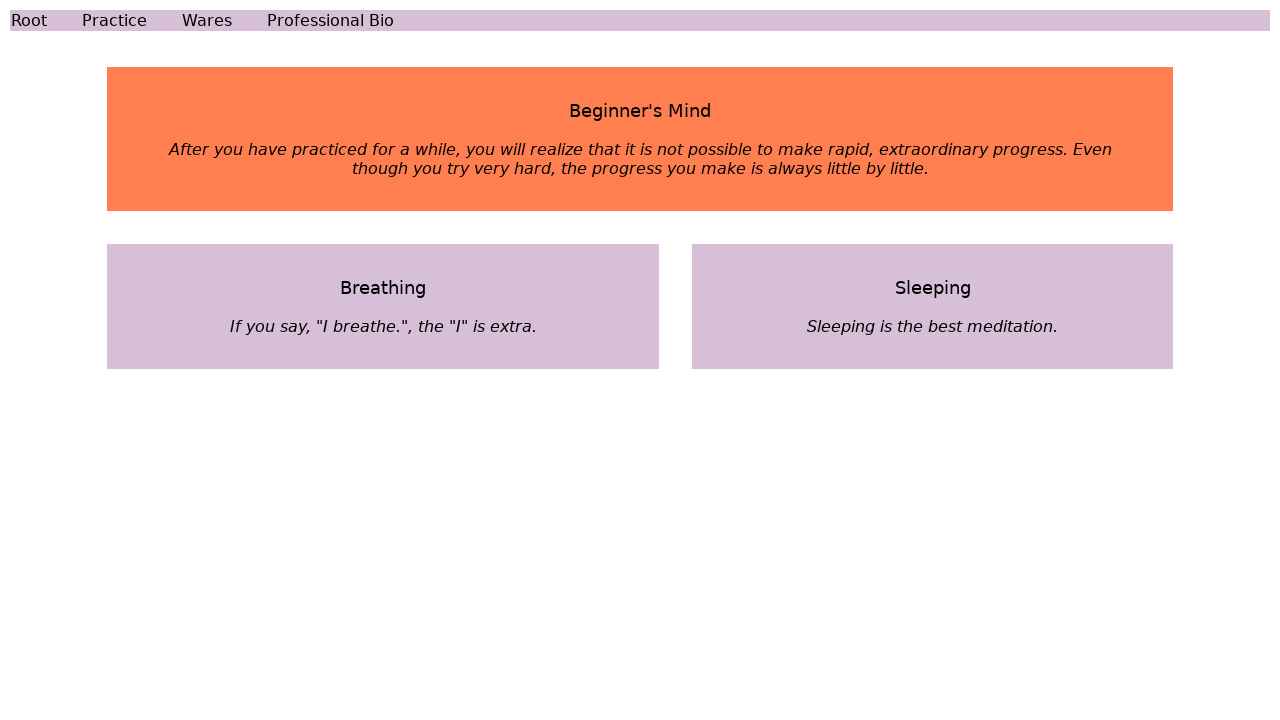How can I start building this website with HTML from the ground up? To start building a website from the ground up using HTML, begin by creating a basic structure for your webpage. Write your HTML code in a text editor and save it with a .html extension. Start with the doctype declaration and the HTML element. Inside, create a 'head' section for metadata and links to CSS files, and a 'body' section for the content. Here's a simple template:

<!DOCTYPE html>
<html lang="en">
<head>
    <meta charset="UTF-8">
    <meta name="viewport" content="width=device-width, initial-scale=1.0">
    <title>Your Website Title Here</title>
</head>
<body>
    <h1>Welcome to My Website</h1>
    <p>This is a paragraph of text.</p>
</body>
</html>

Test your page by opening it in a web browser. Continue learning HTML and CSS to enhance the design and functionality of your site. 